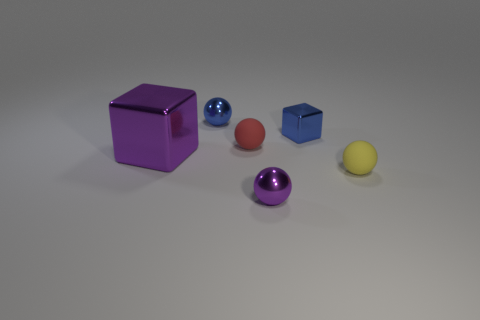Subtract all yellow balls. How many balls are left? 3 Add 2 tiny green metallic cylinders. How many objects exist? 8 Subtract all yellow spheres. How many spheres are left? 3 Subtract 1 balls. How many balls are left? 3 Add 5 small yellow things. How many small yellow things are left? 6 Add 5 purple objects. How many purple objects exist? 7 Subtract 0 green balls. How many objects are left? 6 Subtract all spheres. How many objects are left? 2 Subtract all cyan balls. Subtract all purple cylinders. How many balls are left? 4 Subtract all gray spheres. How many green cubes are left? 0 